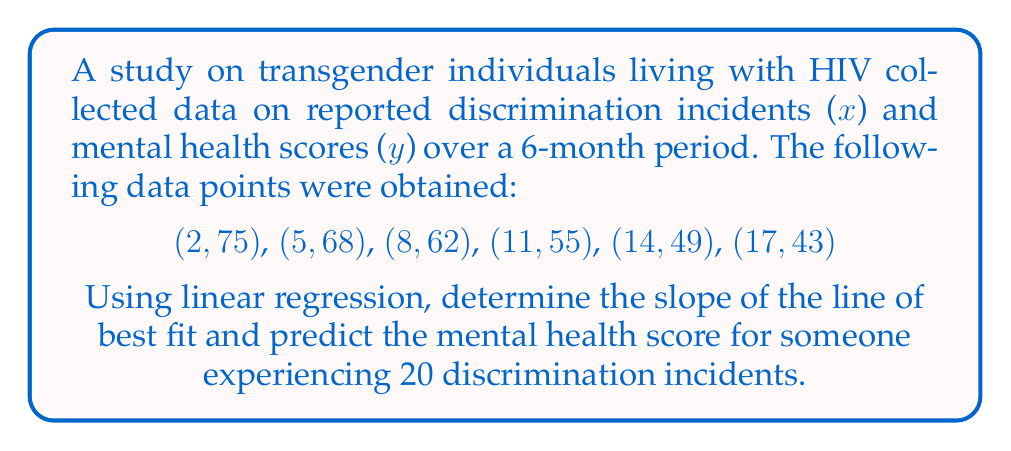Show me your answer to this math problem. 1. Calculate the means of x and y:
   $\bar{x} = \frac{2 + 5 + 8 + 11 + 14 + 17}{6} = 9.5$
   $\bar{y} = \frac{75 + 68 + 62 + 55 + 49 + 43}{6} = 58.67$

2. Calculate $\sum (x - \bar{x})(y - \bar{y})$ and $\sum (x - \bar{x})^2$:
   $\sum (x - \bar{x})(y - \bar{y}) = (-7.5)(16.33) + (-4.5)(9.33) + (-1.5)(3.33) + (1.5)(-3.67) + (4.5)(-9.67) + (7.5)(-15.67) = -535$
   $\sum (x - \bar{x})^2 = (-7.5)^2 + (-4.5)^2 + (-1.5)^2 + (1.5)^2 + (4.5)^2 + (7.5)^2 = 189$

3. Calculate the slope (m) of the line of best fit:
   $m = \frac{\sum (x - \bar{x})(y - \bar{y})}{\sum (x - \bar{x})^2} = \frac{-535}{189} = -2.83$

4. Calculate the y-intercept (b) using $y = mx + b$:
   $58.67 = -2.83(9.5) + b$
   $b = 58.67 + 26.89 = 85.56$

5. The equation of the line of best fit is:
   $y = -2.83x + 85.56$

6. Predict the mental health score for x = 20:
   $y = -2.83(20) + 85.56 = 29.06$
Answer: $m = -2.83$, $y(20) = 29.06$ 